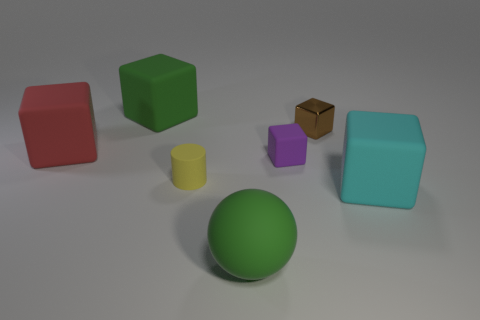Is there anything else that has the same shape as the yellow thing?
Your answer should be compact. No. What number of other objects are the same shape as the small brown object?
Offer a very short reply. 4. What is the color of the sphere that is the same size as the red rubber object?
Provide a succinct answer. Green. How many things are tiny gray rubber balls or matte balls?
Your answer should be very brief. 1. Are there any large objects behind the large ball?
Offer a terse response. Yes. Are there any other small cyan things made of the same material as the cyan thing?
Ensure brevity in your answer.  No. What is the size of the cube that is the same color as the big sphere?
Give a very brief answer. Large. What number of balls are either big rubber things or small purple things?
Your response must be concise. 1. Is the number of brown metal objects that are in front of the cyan object greater than the number of large green things that are to the right of the metallic object?
Give a very brief answer. No. What number of large rubber objects have the same color as the tiny matte cylinder?
Provide a short and direct response. 0. 